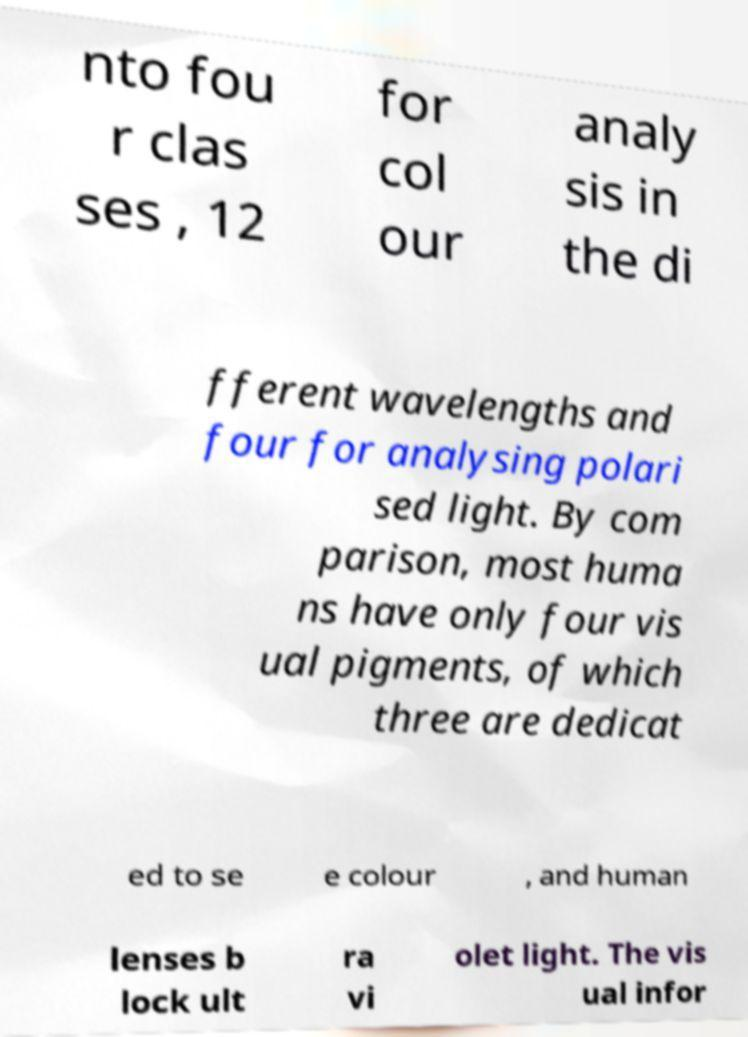Could you extract and type out the text from this image? nto fou r clas ses , 12 for col our analy sis in the di fferent wavelengths and four for analysing polari sed light. By com parison, most huma ns have only four vis ual pigments, of which three are dedicat ed to se e colour , and human lenses b lock ult ra vi olet light. The vis ual infor 